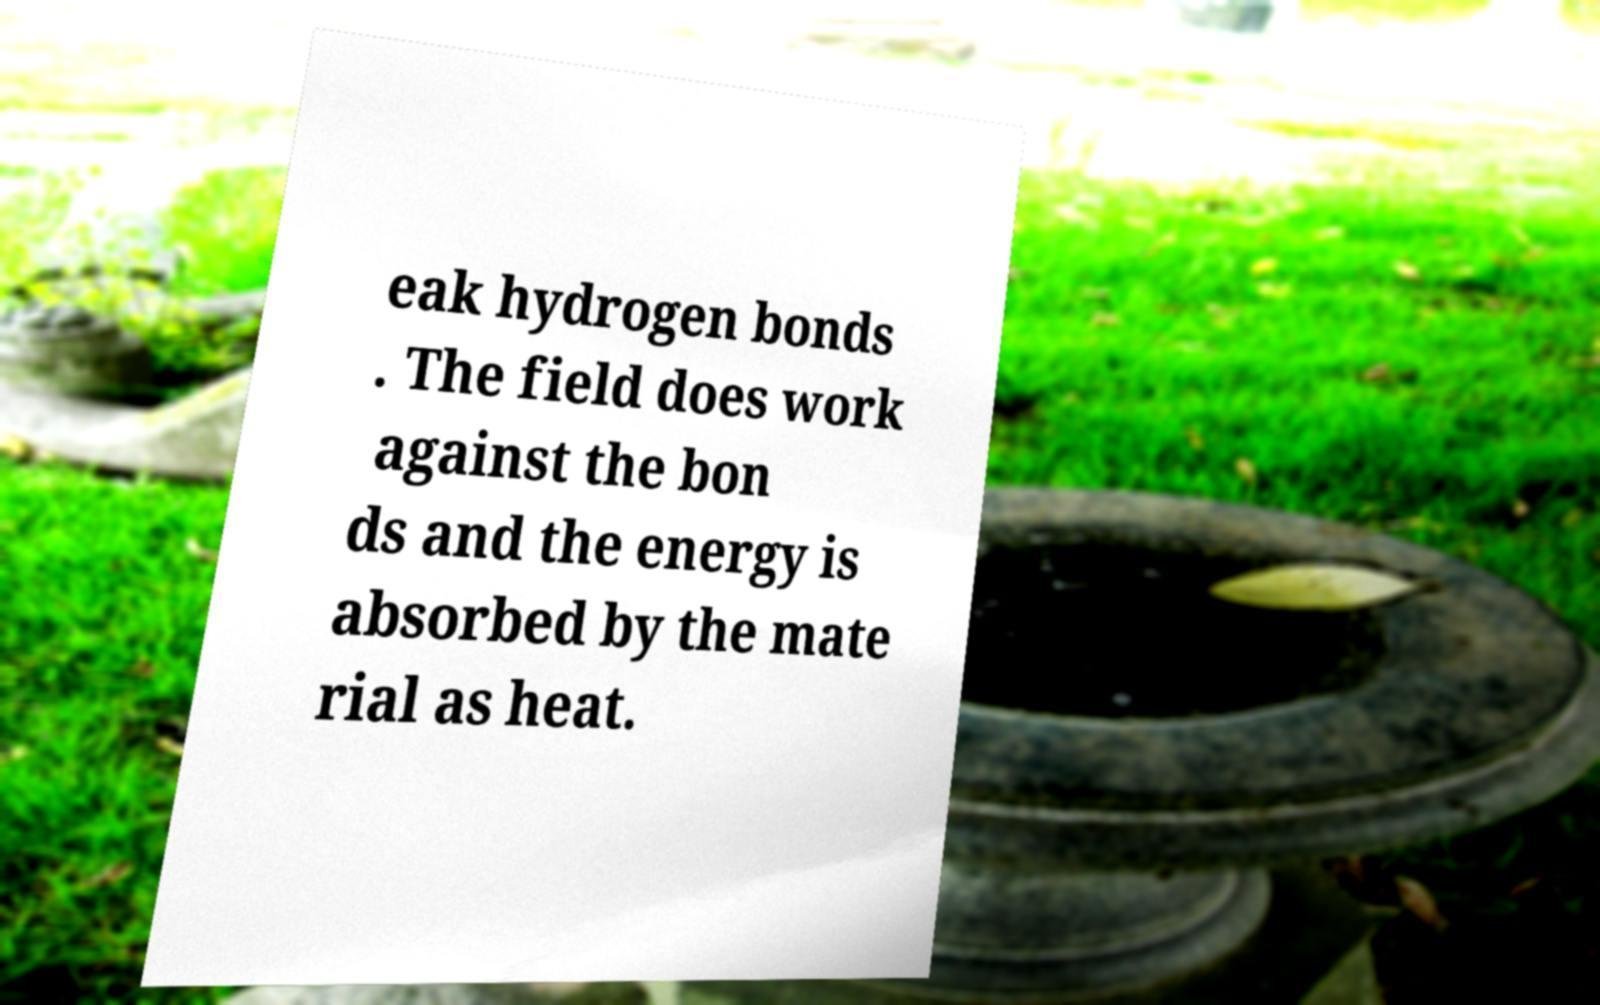Can you read and provide the text displayed in the image?This photo seems to have some interesting text. Can you extract and type it out for me? eak hydrogen bonds . The field does work against the bon ds and the energy is absorbed by the mate rial as heat. 